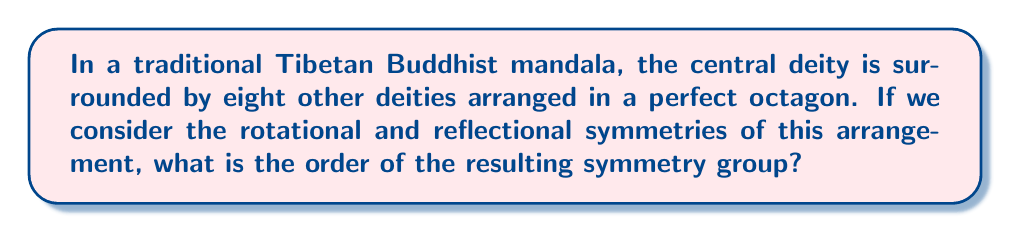Solve this math problem. To solve this problem, let's approach it step-by-step:

1) First, we need to identify the symmetries present in the mandala:

   a) Rotational symmetries: The octagonal arrangement allows for rotations of 45°, 90°, 135°, 180°, 225°, 270°, and 315°, as well as the identity rotation (0° or 360°). This gives us 8 rotational symmetries.

   b) Reflectional symmetries: An octagon has 8 lines of reflection - 4 passing through opposite vertices and 4 passing through the midpoints of opposite sides.

2) The symmetry group of an octagon is known as the dihedral group $D_8$.

3) The order of a dihedral group $D_n$ is given by the formula:

   $$|D_n| = 2n$$

   Where $n$ is the number of sides in the regular polygon.

4) In this case, $n = 8$, so we have:

   $$|D_8| = 2 \cdot 8 = 16$$

5) We can verify this by counting the symmetries:
   - 8 rotational symmetries
   - 8 reflectional symmetries
   Total: 16 symmetries

Therefore, the order of the symmetry group of this mandala arrangement is 16.
Answer: The order of the symmetry group is 16. 